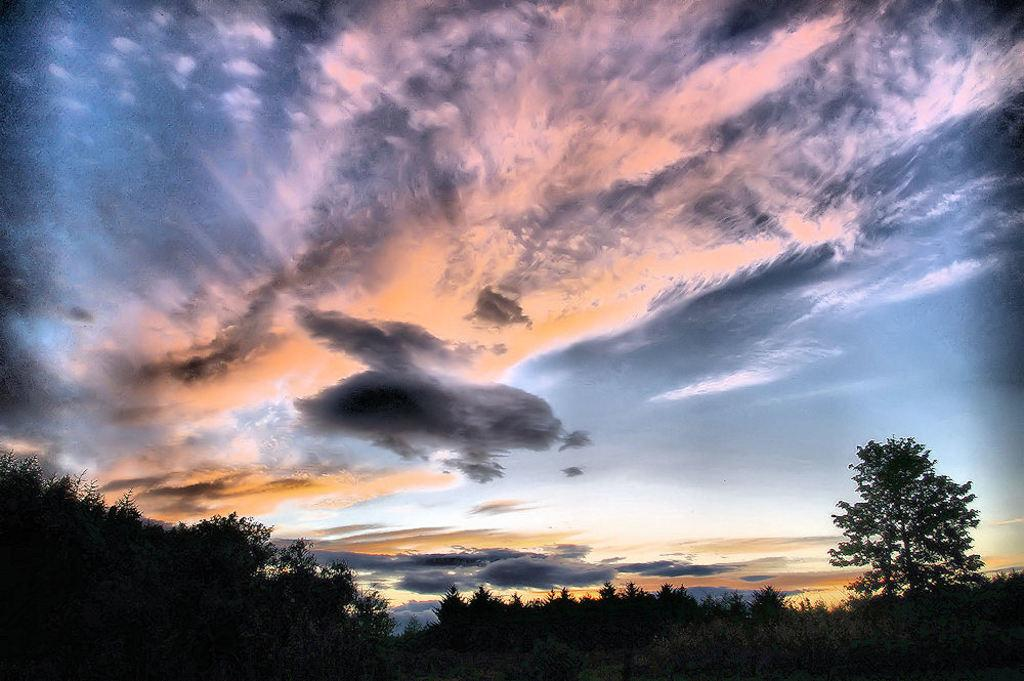What type of vegetation can be seen in the image? There are trees in the image. What part of the natural environment is visible in the image? The sky is visible in the image. What colors can be seen in the sky in the image? The sky has colors orange, blue, white, and black. What are the thoughts of the trees in the image? Trees do not have thoughts, as they are inanimate objects. 